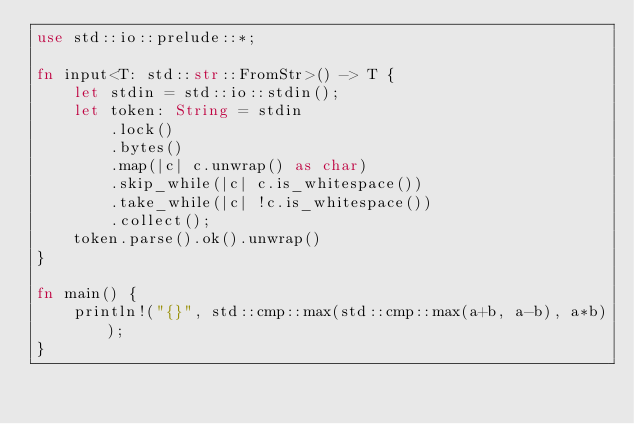<code> <loc_0><loc_0><loc_500><loc_500><_Rust_>use std::io::prelude::*;

fn input<T: std::str::FromStr>() -> T {
    let stdin = std::io::stdin();
    let token: String = stdin
        .lock()
        .bytes()
        .map(|c| c.unwrap() as char)
        .skip_while(|c| c.is_whitespace())
        .take_while(|c| !c.is_whitespace())
        .collect();
    token.parse().ok().unwrap()
}

fn main() {
    println!("{}", std::cmp::max(std::cmp::max(a+b, a-b), a*b));
}
</code> 